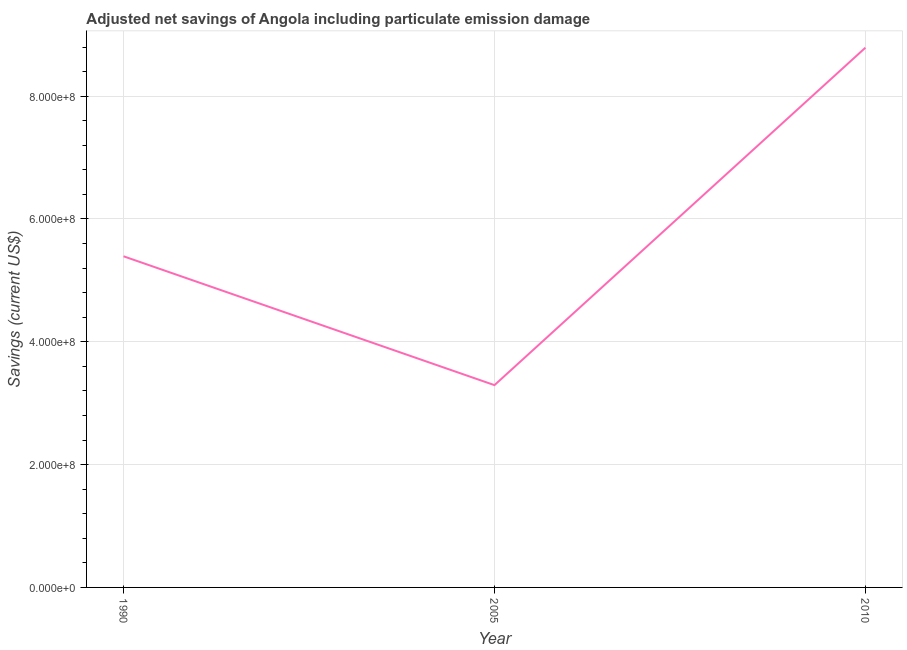What is the adjusted net savings in 2005?
Your answer should be compact. 3.29e+08. Across all years, what is the maximum adjusted net savings?
Provide a short and direct response. 8.79e+08. Across all years, what is the minimum adjusted net savings?
Provide a short and direct response. 3.29e+08. What is the sum of the adjusted net savings?
Offer a very short reply. 1.75e+09. What is the difference between the adjusted net savings in 2005 and 2010?
Give a very brief answer. -5.49e+08. What is the average adjusted net savings per year?
Offer a very short reply. 5.83e+08. What is the median adjusted net savings?
Offer a very short reply. 5.39e+08. Do a majority of the years between 1990 and 2010 (inclusive) have adjusted net savings greater than 80000000 US$?
Provide a succinct answer. Yes. What is the ratio of the adjusted net savings in 1990 to that in 2010?
Provide a succinct answer. 0.61. What is the difference between the highest and the second highest adjusted net savings?
Offer a terse response. 3.40e+08. What is the difference between the highest and the lowest adjusted net savings?
Your answer should be very brief. 5.49e+08. In how many years, is the adjusted net savings greater than the average adjusted net savings taken over all years?
Your answer should be compact. 1. How many lines are there?
Your answer should be compact. 1. What is the difference between two consecutive major ticks on the Y-axis?
Offer a very short reply. 2.00e+08. Are the values on the major ticks of Y-axis written in scientific E-notation?
Offer a very short reply. Yes. Does the graph contain any zero values?
Your response must be concise. No. Does the graph contain grids?
Your answer should be compact. Yes. What is the title of the graph?
Offer a very short reply. Adjusted net savings of Angola including particulate emission damage. What is the label or title of the X-axis?
Ensure brevity in your answer.  Year. What is the label or title of the Y-axis?
Provide a short and direct response. Savings (current US$). What is the Savings (current US$) in 1990?
Provide a short and direct response. 5.39e+08. What is the Savings (current US$) of 2005?
Provide a succinct answer. 3.29e+08. What is the Savings (current US$) in 2010?
Make the answer very short. 8.79e+08. What is the difference between the Savings (current US$) in 1990 and 2005?
Provide a short and direct response. 2.10e+08. What is the difference between the Savings (current US$) in 1990 and 2010?
Your answer should be compact. -3.40e+08. What is the difference between the Savings (current US$) in 2005 and 2010?
Give a very brief answer. -5.49e+08. What is the ratio of the Savings (current US$) in 1990 to that in 2005?
Offer a terse response. 1.64. What is the ratio of the Savings (current US$) in 1990 to that in 2010?
Give a very brief answer. 0.61. 